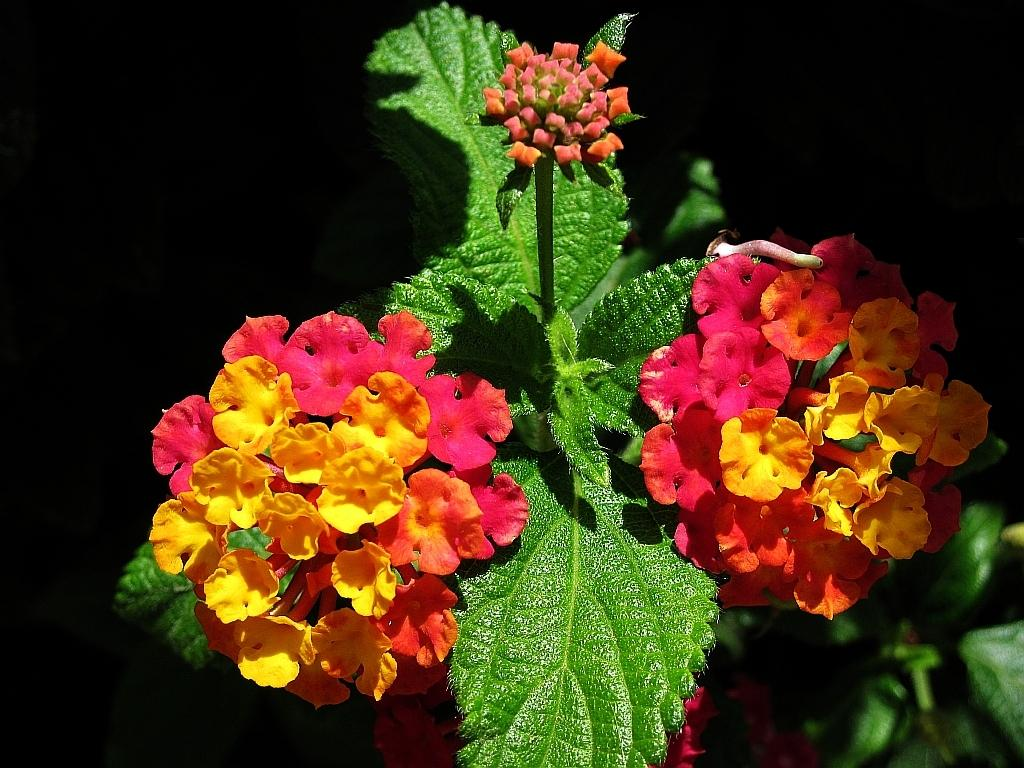What type of plants can be seen in the image? There are colorful flowers in the image. What else can be seen in the image besides the flowers? There are leaves in the image. What is the color of the background in the image? The background of the image is black. What is the name of the team that is playing in the image? There is no team or any indication of a game in the image; it features colorful flowers and leaves against a black background. 